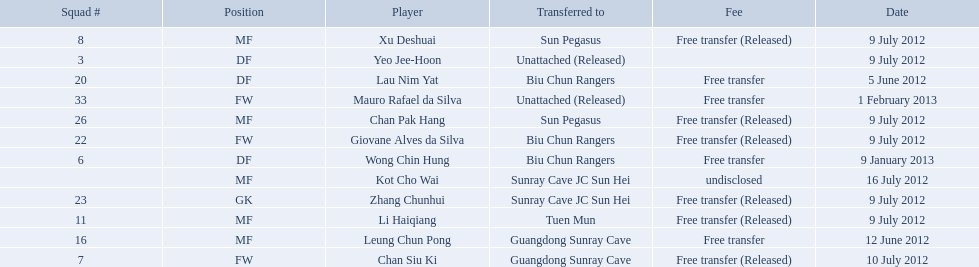On what dates were there non released free transfers? 5 June 2012, 12 June 2012, 9 January 2013, 1 February 2013. On which of these were the players transferred to another team? 5 June 2012, 12 June 2012, 9 January 2013. Which of these were the transfers to biu chun rangers? 5 June 2012, 9 January 2013. On which of those dated did they receive a df? 9 January 2013. 